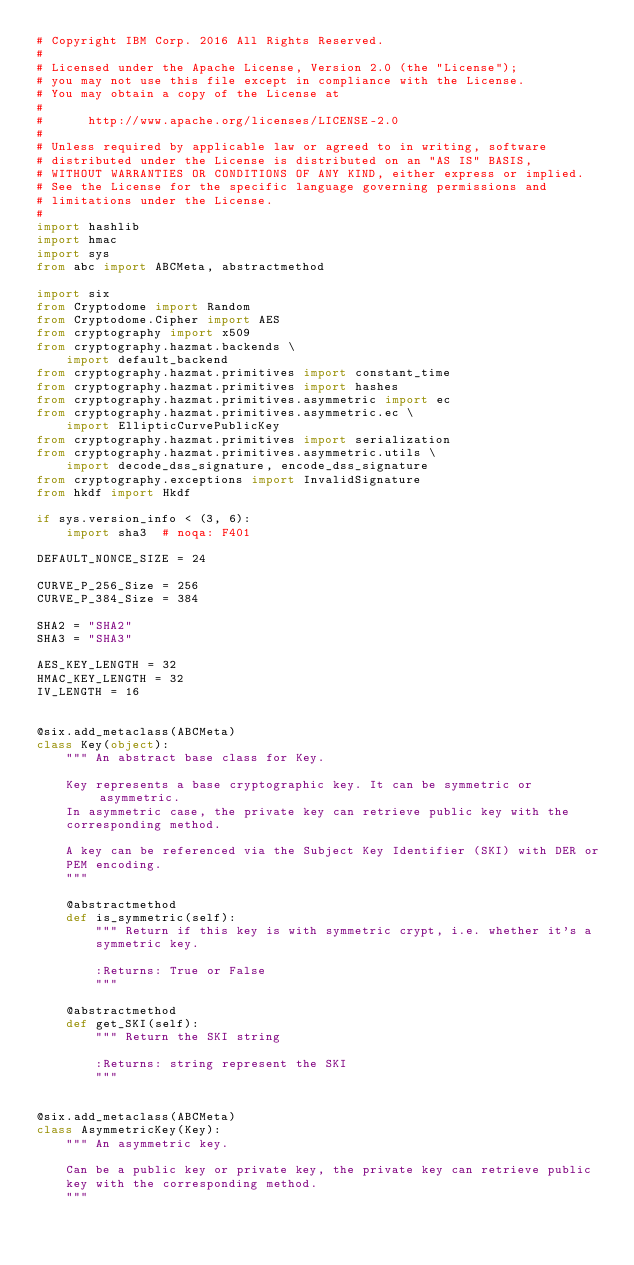Convert code to text. <code><loc_0><loc_0><loc_500><loc_500><_Python_># Copyright IBM Corp. 2016 All Rights Reserved.
#
# Licensed under the Apache License, Version 2.0 (the "License");
# you may not use this file except in compliance with the License.
# You may obtain a copy of the License at
#
#      http://www.apache.org/licenses/LICENSE-2.0
#
# Unless required by applicable law or agreed to in writing, software
# distributed under the License is distributed on an "AS IS" BASIS,
# WITHOUT WARRANTIES OR CONDITIONS OF ANY KIND, either express or implied.
# See the License for the specific language governing permissions and
# limitations under the License.
#
import hashlib
import hmac
import sys
from abc import ABCMeta, abstractmethod

import six
from Cryptodome import Random
from Cryptodome.Cipher import AES
from cryptography import x509
from cryptography.hazmat.backends \
    import default_backend
from cryptography.hazmat.primitives import constant_time
from cryptography.hazmat.primitives import hashes
from cryptography.hazmat.primitives.asymmetric import ec
from cryptography.hazmat.primitives.asymmetric.ec \
    import EllipticCurvePublicKey
from cryptography.hazmat.primitives import serialization
from cryptography.hazmat.primitives.asymmetric.utils \
    import decode_dss_signature, encode_dss_signature
from cryptography.exceptions import InvalidSignature
from hkdf import Hkdf

if sys.version_info < (3, 6):
    import sha3  # noqa: F401

DEFAULT_NONCE_SIZE = 24

CURVE_P_256_Size = 256
CURVE_P_384_Size = 384

SHA2 = "SHA2"
SHA3 = "SHA3"

AES_KEY_LENGTH = 32
HMAC_KEY_LENGTH = 32
IV_LENGTH = 16


@six.add_metaclass(ABCMeta)
class Key(object):
    """ An abstract base class for Key.

    Key represents a base cryptographic key. It can be symmetric or asymmetric.
    In asymmetric case, the private key can retrieve public key with the
    corresponding method.

    A key can be referenced via the Subject Key Identifier (SKI) with DER or
    PEM encoding.
    """

    @abstractmethod
    def is_symmetric(self):
        """ Return if this key is with symmetric crypt, i.e. whether it's a
        symmetric key.

        :Returns: True or False
        """

    @abstractmethod
    def get_SKI(self):
        """ Return the SKI string

        :Returns: string represent the SKI
        """


@six.add_metaclass(ABCMeta)
class AsymmetricKey(Key):
    """ An asymmetric key.

    Can be a public key or private key, the private key can retrieve public
    key with the corresponding method.
    """
</code> 